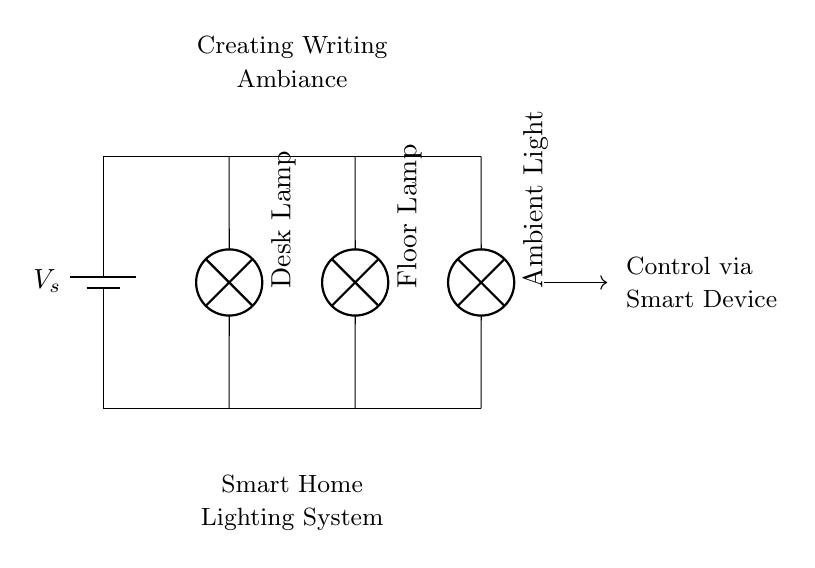What are the components in the circuit? The circuit includes a battery, a desk lamp, a floor lamp, and an ambient light. These are visually represented as distinct symbols within the diagram.
Answer: battery, desk lamp, floor lamp, ambient light What type of circuit is represented here? The components are connected in such a way that each lamp is connected directly across the power source, which classifies this circuit as a parallel circuit.
Answer: parallel How many lamps are in the circuit? By counting, there are three lamps illustrated in the circuit diagram: a desk lamp, a floor lamp, and an ambient light.
Answer: three What does the arrow symbol indicate in the circuit? The arrow represents the direction of control from the smart device to the circuit system, indicating that the lighting can be operated remotely.
Answer: control direction If one lamp fails, will the others stay on? In a parallel circuit, each component operates independently, so if one lamp fails, the other lamps will continue to function normally.
Answer: yes What is the primary purpose of this circuit? The circuit is designed to create a specific ambiance for writing in a smart home environment by utilizing multiple light sources.
Answer: creating ambiance 